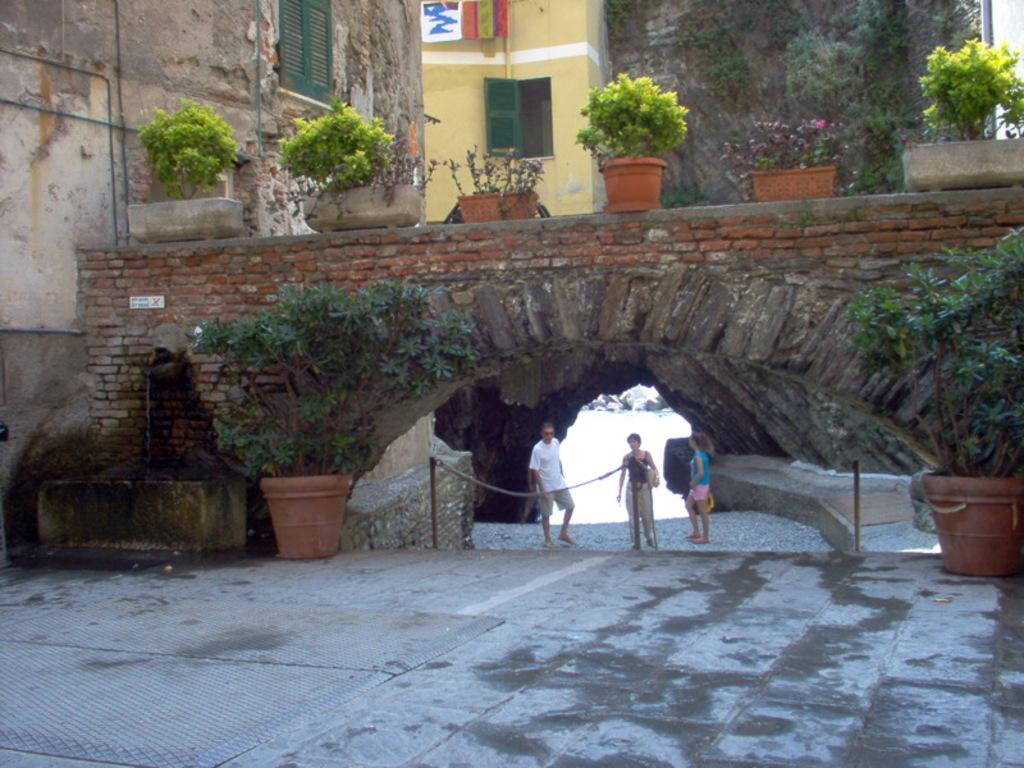What is the man in the image doing? The man is walking in the image. What is the man wearing? The man is wearing a white t-shirt. Who is accompanying the man in the image? There are two girls walking beside the man. Where does the scene take place? The scene takes place on a bridge. What can be seen on the left side of the image? There is a monument on the left side of the image. What is present near the monument? Trees are present near the monument. What type of pollution can be seen in the image? There is no pollution visible in the image. What treatment is being administered to the man in the image? There is no treatment being administered to the man in the image; he is simply walking. 